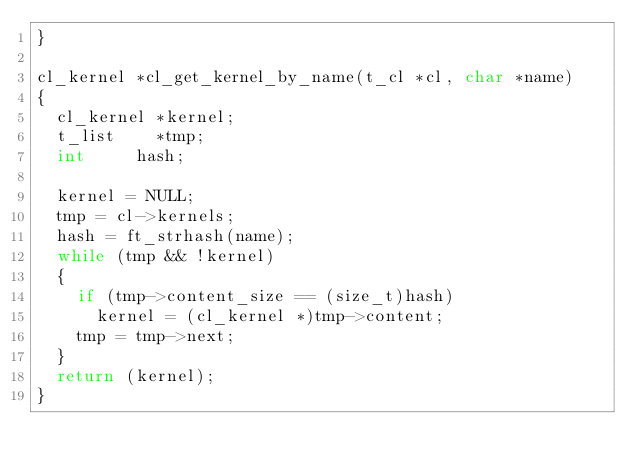<code> <loc_0><loc_0><loc_500><loc_500><_C_>}

cl_kernel	*cl_get_kernel_by_name(t_cl *cl, char *name)
{
	cl_kernel	*kernel;
	t_list		*tmp;
	int			hash;

	kernel = NULL;
	tmp = cl->kernels;
	hash = ft_strhash(name);
	while (tmp && !kernel)
	{
		if (tmp->content_size == (size_t)hash)
			kernel = (cl_kernel *)tmp->content;
		tmp = tmp->next;
	}
	return (kernel);
}
</code> 